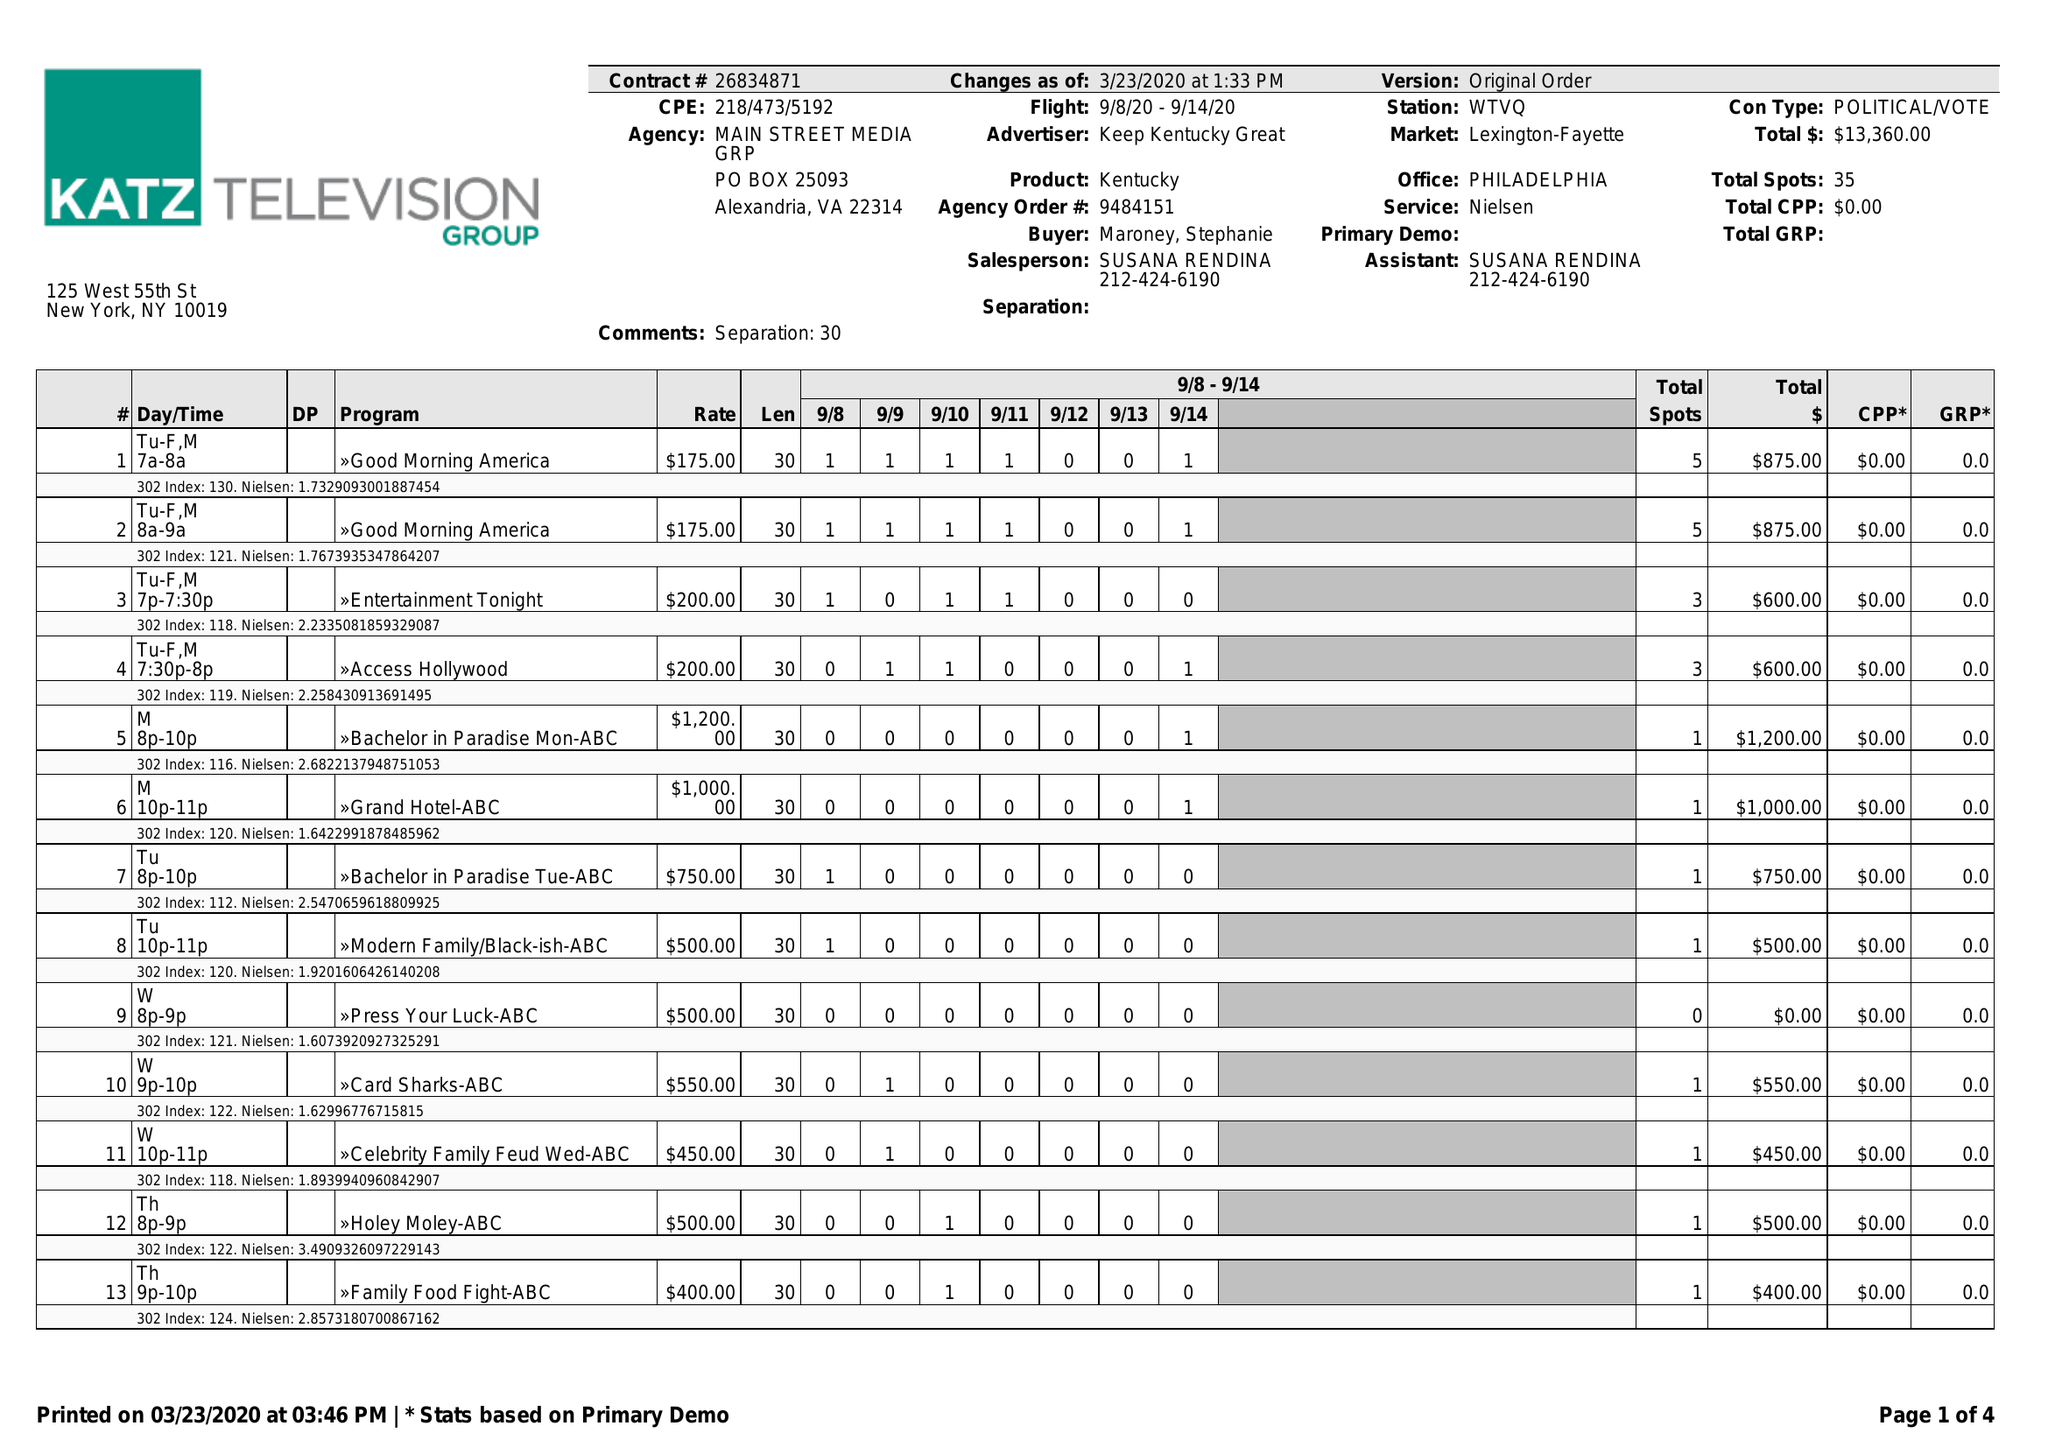What is the value for the contract_num?
Answer the question using a single word or phrase. 26834871 